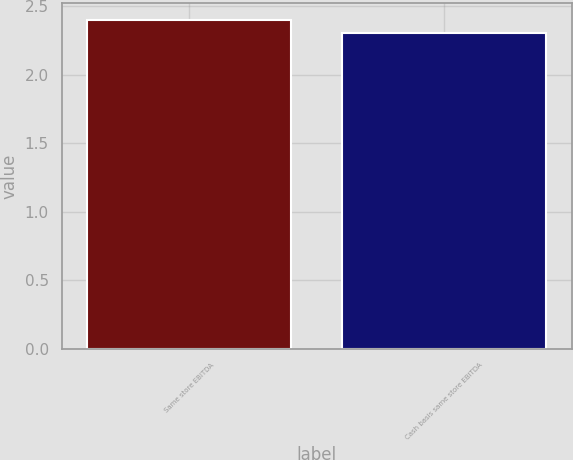Convert chart to OTSL. <chart><loc_0><loc_0><loc_500><loc_500><bar_chart><fcel>Same store EBITDA<fcel>Cash basis same store EBITDA<nl><fcel>2.4<fcel>2.3<nl></chart> 